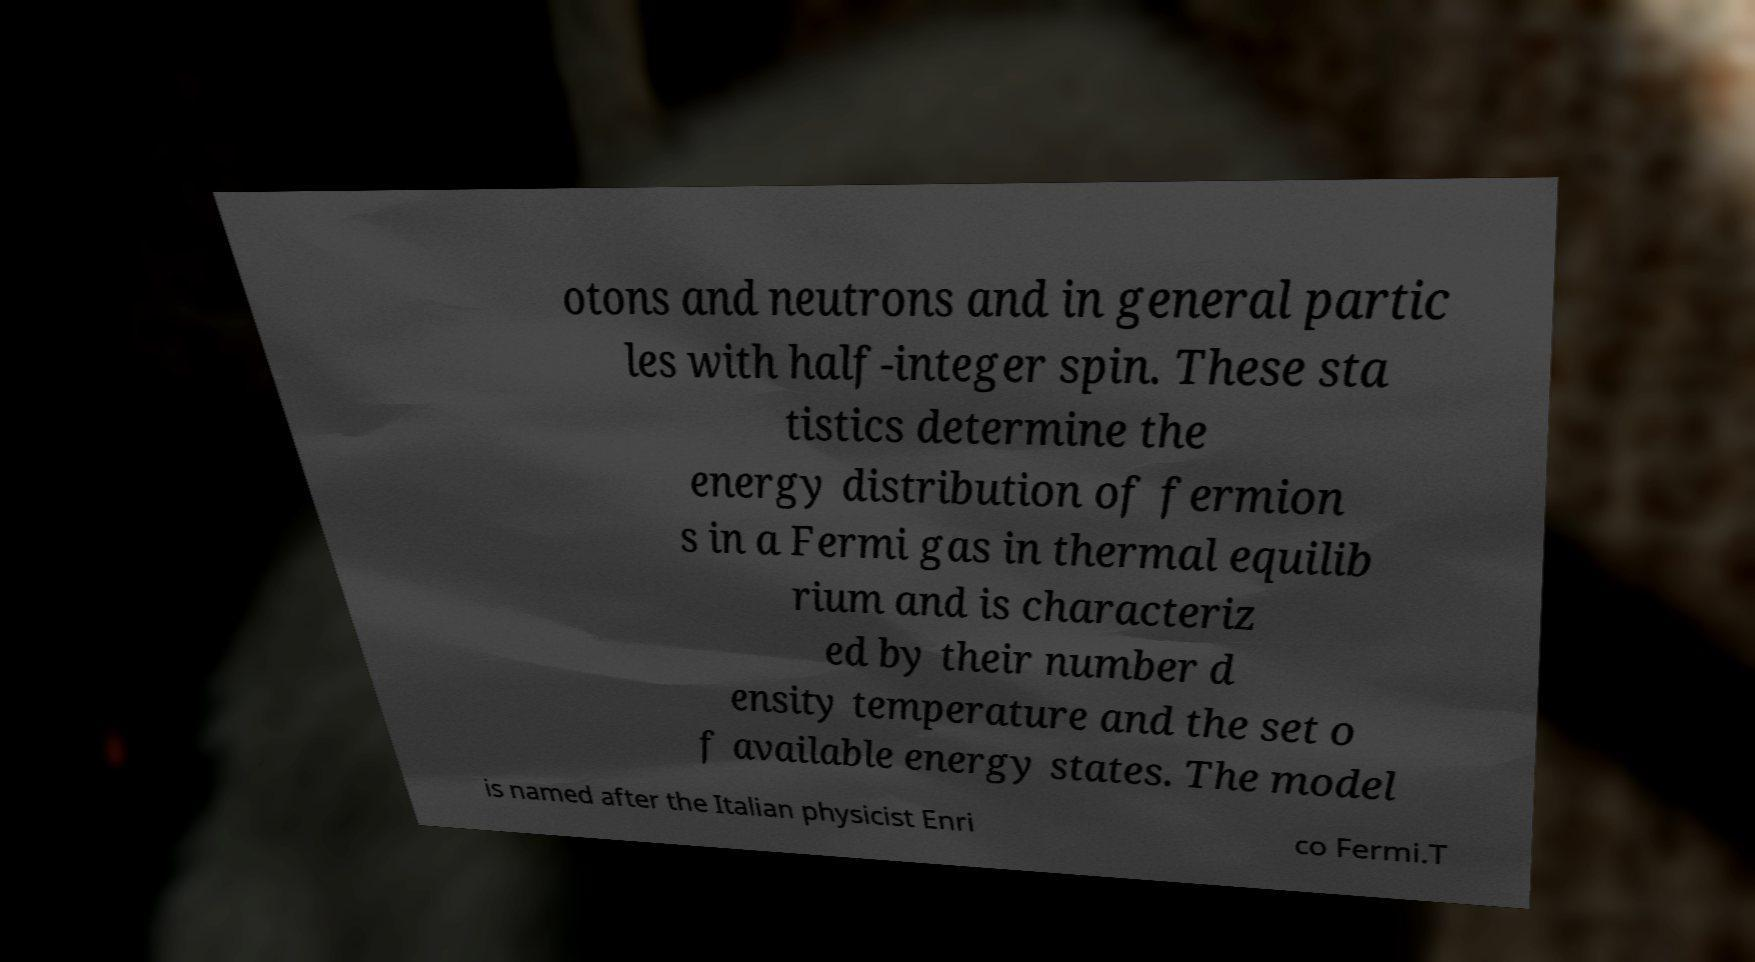I need the written content from this picture converted into text. Can you do that? otons and neutrons and in general partic les with half-integer spin. These sta tistics determine the energy distribution of fermion s in a Fermi gas in thermal equilib rium and is characteriz ed by their number d ensity temperature and the set o f available energy states. The model is named after the Italian physicist Enri co Fermi.T 